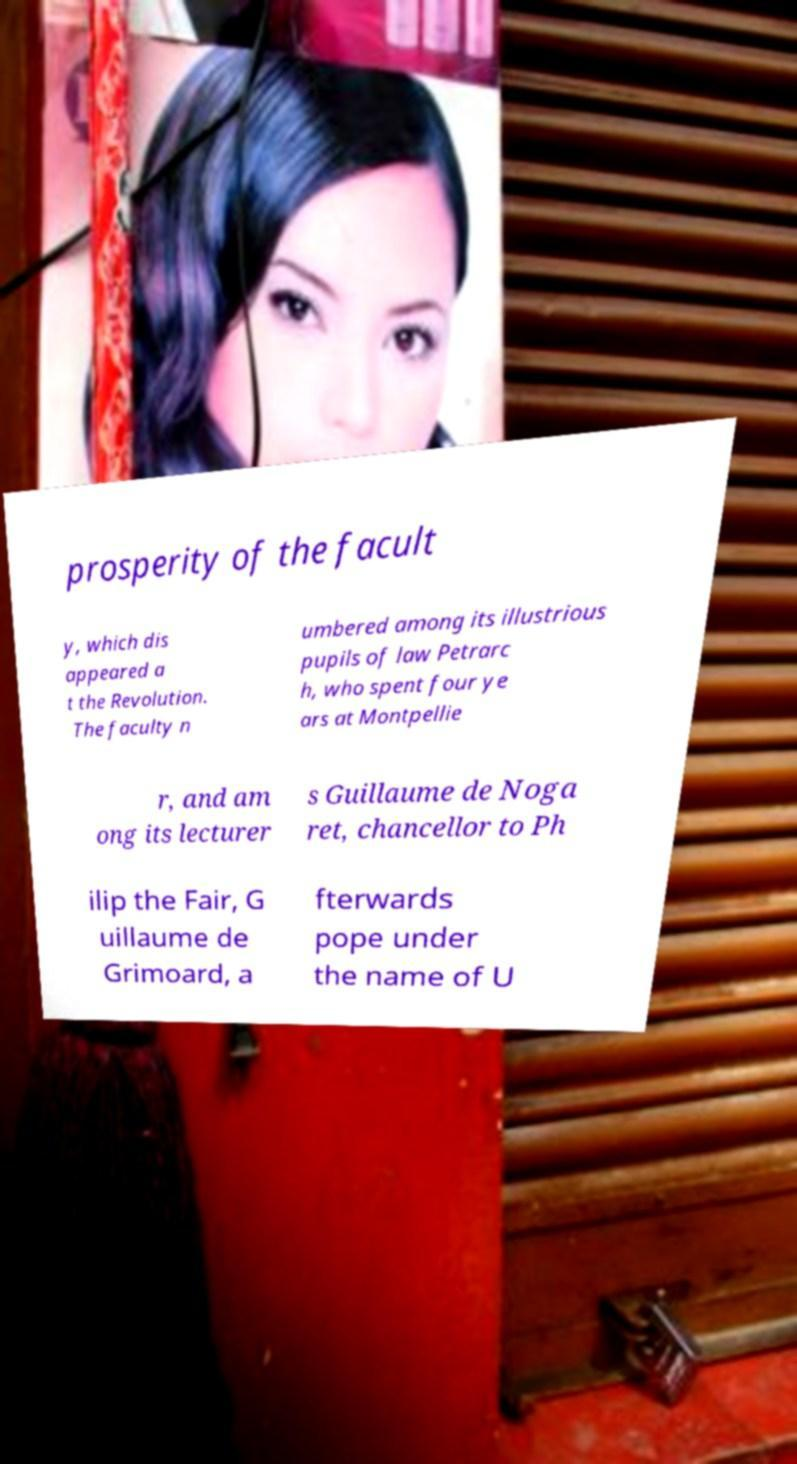Please identify and transcribe the text found in this image. prosperity of the facult y, which dis appeared a t the Revolution. The faculty n umbered among its illustrious pupils of law Petrarc h, who spent four ye ars at Montpellie r, and am ong its lecturer s Guillaume de Noga ret, chancellor to Ph ilip the Fair, G uillaume de Grimoard, a fterwards pope under the name of U 